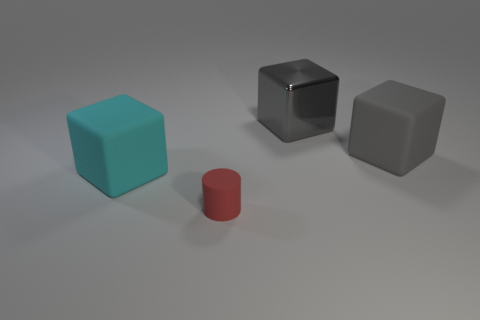Subtract all large shiny blocks. How many blocks are left? 2 Subtract all cyan blocks. How many blocks are left? 2 Add 2 tiny red rubber cylinders. How many objects exist? 6 Subtract all yellow cylinders. Subtract all purple blocks. How many cylinders are left? 1 Subtract all green balls. How many green cylinders are left? 0 Subtract all small rubber things. Subtract all big matte cubes. How many objects are left? 1 Add 4 cyan matte objects. How many cyan matte objects are left? 5 Add 1 tiny red matte cylinders. How many tiny red matte cylinders exist? 2 Subtract 0 blue spheres. How many objects are left? 4 Subtract all cubes. How many objects are left? 1 